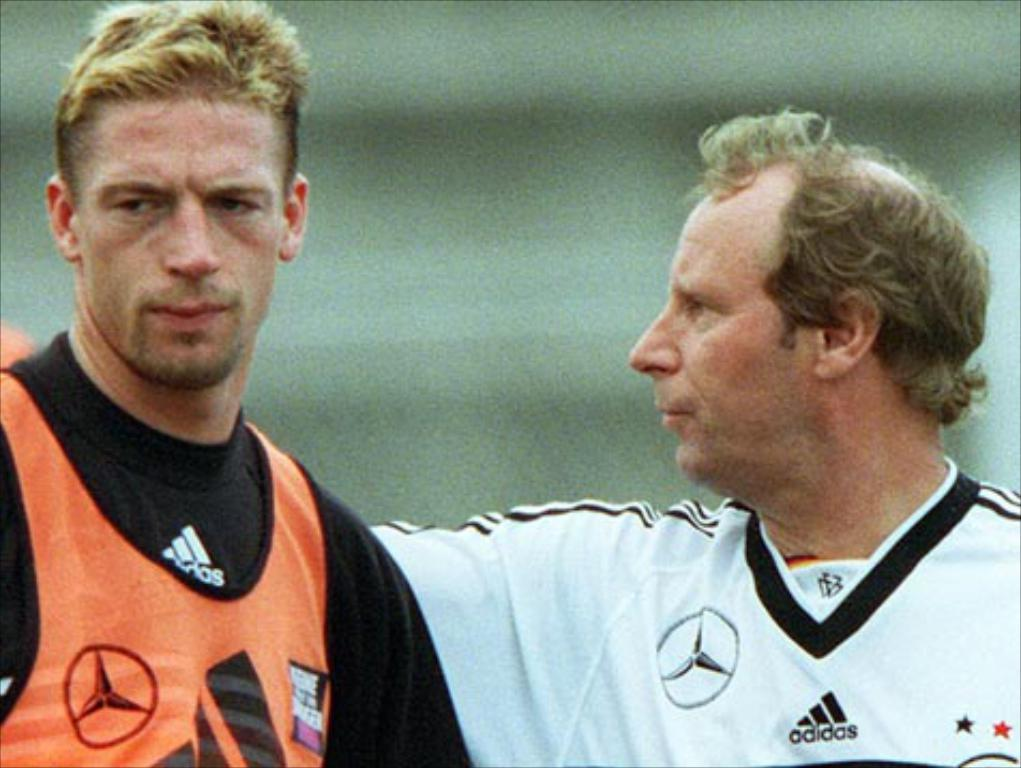Provide a one-sentence caption for the provided image. two men with adidas jerseys with unhappy looks on their faces. 